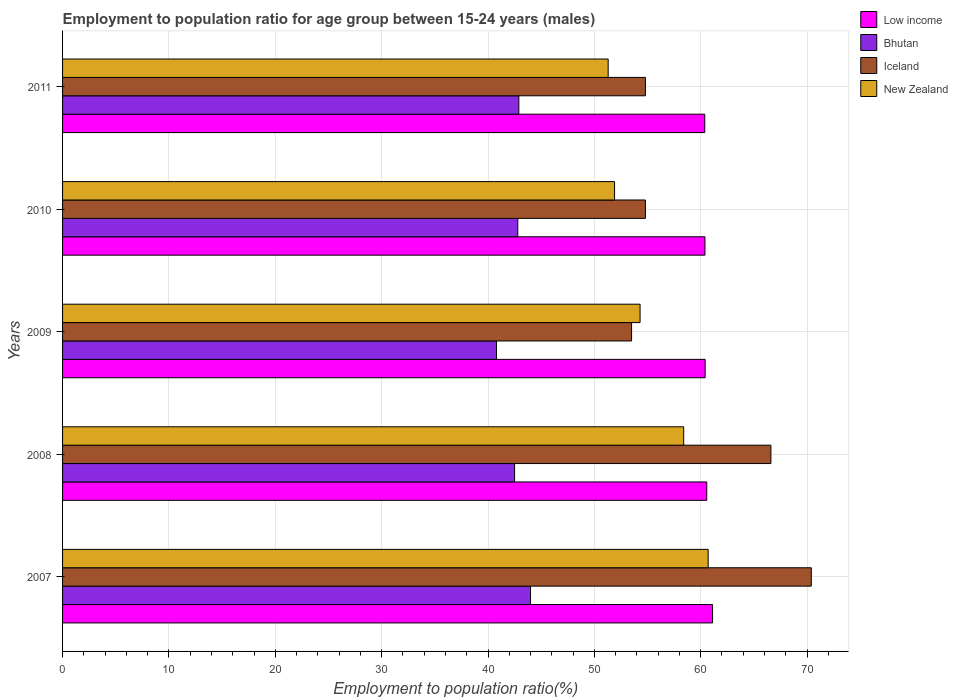How many different coloured bars are there?
Your response must be concise. 4. Are the number of bars on each tick of the Y-axis equal?
Keep it short and to the point. Yes. How many bars are there on the 3rd tick from the bottom?
Give a very brief answer. 4. What is the label of the 3rd group of bars from the top?
Ensure brevity in your answer.  2009. In how many cases, is the number of bars for a given year not equal to the number of legend labels?
Your answer should be very brief. 0. What is the employment to population ratio in New Zealand in 2009?
Offer a terse response. 54.3. Across all years, what is the maximum employment to population ratio in Iceland?
Provide a succinct answer. 70.4. Across all years, what is the minimum employment to population ratio in Bhutan?
Your answer should be compact. 40.8. In which year was the employment to population ratio in Iceland maximum?
Ensure brevity in your answer.  2007. What is the total employment to population ratio in Bhutan in the graph?
Offer a terse response. 213. What is the difference between the employment to population ratio in New Zealand in 2008 and that in 2009?
Provide a succinct answer. 4.1. What is the difference between the employment to population ratio in Iceland in 2010 and the employment to population ratio in Bhutan in 2008?
Make the answer very short. 12.3. What is the average employment to population ratio in Iceland per year?
Ensure brevity in your answer.  60.02. In the year 2009, what is the difference between the employment to population ratio in Low income and employment to population ratio in Iceland?
Give a very brief answer. 6.92. What is the ratio of the employment to population ratio in Iceland in 2008 to that in 2010?
Your response must be concise. 1.22. What is the difference between the highest and the second highest employment to population ratio in Low income?
Offer a very short reply. 0.55. What is the difference between the highest and the lowest employment to population ratio in Iceland?
Your answer should be compact. 16.9. In how many years, is the employment to population ratio in Bhutan greater than the average employment to population ratio in Bhutan taken over all years?
Give a very brief answer. 3. Is the sum of the employment to population ratio in Low income in 2009 and 2010 greater than the maximum employment to population ratio in Iceland across all years?
Keep it short and to the point. Yes. Is it the case that in every year, the sum of the employment to population ratio in Iceland and employment to population ratio in Low income is greater than the sum of employment to population ratio in Bhutan and employment to population ratio in New Zealand?
Provide a short and direct response. Yes. What does the 3rd bar from the top in 2010 represents?
Keep it short and to the point. Bhutan. What does the 4th bar from the bottom in 2010 represents?
Give a very brief answer. New Zealand. Is it the case that in every year, the sum of the employment to population ratio in New Zealand and employment to population ratio in Bhutan is greater than the employment to population ratio in Iceland?
Ensure brevity in your answer.  Yes. How many bars are there?
Ensure brevity in your answer.  20. Are all the bars in the graph horizontal?
Ensure brevity in your answer.  Yes. How many years are there in the graph?
Your answer should be compact. 5. Does the graph contain any zero values?
Your answer should be compact. No. Does the graph contain grids?
Provide a short and direct response. Yes. Where does the legend appear in the graph?
Offer a terse response. Top right. How many legend labels are there?
Your response must be concise. 4. How are the legend labels stacked?
Keep it short and to the point. Vertical. What is the title of the graph?
Provide a short and direct response. Employment to population ratio for age group between 15-24 years (males). What is the label or title of the X-axis?
Your answer should be compact. Employment to population ratio(%). What is the Employment to population ratio(%) in Low income in 2007?
Provide a succinct answer. 61.11. What is the Employment to population ratio(%) in Bhutan in 2007?
Your answer should be compact. 44. What is the Employment to population ratio(%) of Iceland in 2007?
Your answer should be very brief. 70.4. What is the Employment to population ratio(%) of New Zealand in 2007?
Your response must be concise. 60.7. What is the Employment to population ratio(%) in Low income in 2008?
Ensure brevity in your answer.  60.57. What is the Employment to population ratio(%) of Bhutan in 2008?
Your answer should be compact. 42.5. What is the Employment to population ratio(%) of Iceland in 2008?
Ensure brevity in your answer.  66.6. What is the Employment to population ratio(%) in New Zealand in 2008?
Keep it short and to the point. 58.4. What is the Employment to population ratio(%) in Low income in 2009?
Keep it short and to the point. 60.42. What is the Employment to population ratio(%) of Bhutan in 2009?
Ensure brevity in your answer.  40.8. What is the Employment to population ratio(%) of Iceland in 2009?
Keep it short and to the point. 53.5. What is the Employment to population ratio(%) of New Zealand in 2009?
Your answer should be compact. 54.3. What is the Employment to population ratio(%) of Low income in 2010?
Give a very brief answer. 60.4. What is the Employment to population ratio(%) in Bhutan in 2010?
Make the answer very short. 42.8. What is the Employment to population ratio(%) in Iceland in 2010?
Ensure brevity in your answer.  54.8. What is the Employment to population ratio(%) in New Zealand in 2010?
Give a very brief answer. 51.9. What is the Employment to population ratio(%) in Low income in 2011?
Provide a succinct answer. 60.38. What is the Employment to population ratio(%) of Bhutan in 2011?
Make the answer very short. 42.9. What is the Employment to population ratio(%) of Iceland in 2011?
Provide a succinct answer. 54.8. What is the Employment to population ratio(%) in New Zealand in 2011?
Make the answer very short. 51.3. Across all years, what is the maximum Employment to population ratio(%) of Low income?
Ensure brevity in your answer.  61.11. Across all years, what is the maximum Employment to population ratio(%) of Iceland?
Provide a short and direct response. 70.4. Across all years, what is the maximum Employment to population ratio(%) of New Zealand?
Your answer should be very brief. 60.7. Across all years, what is the minimum Employment to population ratio(%) of Low income?
Keep it short and to the point. 60.38. Across all years, what is the minimum Employment to population ratio(%) in Bhutan?
Make the answer very short. 40.8. Across all years, what is the minimum Employment to population ratio(%) of Iceland?
Your response must be concise. 53.5. Across all years, what is the minimum Employment to population ratio(%) in New Zealand?
Give a very brief answer. 51.3. What is the total Employment to population ratio(%) in Low income in the graph?
Keep it short and to the point. 302.88. What is the total Employment to population ratio(%) of Bhutan in the graph?
Keep it short and to the point. 213. What is the total Employment to population ratio(%) in Iceland in the graph?
Offer a terse response. 300.1. What is the total Employment to population ratio(%) of New Zealand in the graph?
Provide a succinct answer. 276.6. What is the difference between the Employment to population ratio(%) in Low income in 2007 and that in 2008?
Provide a succinct answer. 0.55. What is the difference between the Employment to population ratio(%) of Low income in 2007 and that in 2009?
Offer a terse response. 0.7. What is the difference between the Employment to population ratio(%) of Bhutan in 2007 and that in 2009?
Offer a terse response. 3.2. What is the difference between the Employment to population ratio(%) in Iceland in 2007 and that in 2009?
Make the answer very short. 16.9. What is the difference between the Employment to population ratio(%) of Low income in 2007 and that in 2010?
Your answer should be very brief. 0.72. What is the difference between the Employment to population ratio(%) of Iceland in 2007 and that in 2010?
Ensure brevity in your answer.  15.6. What is the difference between the Employment to population ratio(%) in Low income in 2007 and that in 2011?
Offer a terse response. 0.73. What is the difference between the Employment to population ratio(%) of Low income in 2008 and that in 2009?
Your answer should be compact. 0.15. What is the difference between the Employment to population ratio(%) in Bhutan in 2008 and that in 2009?
Offer a very short reply. 1.7. What is the difference between the Employment to population ratio(%) in New Zealand in 2008 and that in 2009?
Ensure brevity in your answer.  4.1. What is the difference between the Employment to population ratio(%) of Low income in 2008 and that in 2010?
Keep it short and to the point. 0.17. What is the difference between the Employment to population ratio(%) in Bhutan in 2008 and that in 2010?
Your response must be concise. -0.3. What is the difference between the Employment to population ratio(%) of Iceland in 2008 and that in 2010?
Give a very brief answer. 11.8. What is the difference between the Employment to population ratio(%) in Low income in 2008 and that in 2011?
Offer a terse response. 0.19. What is the difference between the Employment to population ratio(%) of Bhutan in 2008 and that in 2011?
Offer a terse response. -0.4. What is the difference between the Employment to population ratio(%) in Iceland in 2008 and that in 2011?
Keep it short and to the point. 11.8. What is the difference between the Employment to population ratio(%) of Low income in 2009 and that in 2010?
Offer a terse response. 0.02. What is the difference between the Employment to population ratio(%) of Iceland in 2009 and that in 2010?
Provide a succinct answer. -1.3. What is the difference between the Employment to population ratio(%) in Low income in 2009 and that in 2011?
Give a very brief answer. 0.03. What is the difference between the Employment to population ratio(%) of Bhutan in 2009 and that in 2011?
Your answer should be very brief. -2.1. What is the difference between the Employment to population ratio(%) in Iceland in 2009 and that in 2011?
Ensure brevity in your answer.  -1.3. What is the difference between the Employment to population ratio(%) in Low income in 2010 and that in 2011?
Ensure brevity in your answer.  0.02. What is the difference between the Employment to population ratio(%) of Low income in 2007 and the Employment to population ratio(%) of Bhutan in 2008?
Provide a short and direct response. 18.61. What is the difference between the Employment to population ratio(%) in Low income in 2007 and the Employment to population ratio(%) in Iceland in 2008?
Offer a very short reply. -5.49. What is the difference between the Employment to population ratio(%) in Low income in 2007 and the Employment to population ratio(%) in New Zealand in 2008?
Make the answer very short. 2.71. What is the difference between the Employment to population ratio(%) of Bhutan in 2007 and the Employment to population ratio(%) of Iceland in 2008?
Make the answer very short. -22.6. What is the difference between the Employment to population ratio(%) of Bhutan in 2007 and the Employment to population ratio(%) of New Zealand in 2008?
Your answer should be very brief. -14.4. What is the difference between the Employment to population ratio(%) of Iceland in 2007 and the Employment to population ratio(%) of New Zealand in 2008?
Make the answer very short. 12. What is the difference between the Employment to population ratio(%) in Low income in 2007 and the Employment to population ratio(%) in Bhutan in 2009?
Ensure brevity in your answer.  20.31. What is the difference between the Employment to population ratio(%) of Low income in 2007 and the Employment to population ratio(%) of Iceland in 2009?
Make the answer very short. 7.61. What is the difference between the Employment to population ratio(%) of Low income in 2007 and the Employment to population ratio(%) of New Zealand in 2009?
Offer a terse response. 6.81. What is the difference between the Employment to population ratio(%) of Bhutan in 2007 and the Employment to population ratio(%) of New Zealand in 2009?
Provide a succinct answer. -10.3. What is the difference between the Employment to population ratio(%) of Iceland in 2007 and the Employment to population ratio(%) of New Zealand in 2009?
Offer a terse response. 16.1. What is the difference between the Employment to population ratio(%) in Low income in 2007 and the Employment to population ratio(%) in Bhutan in 2010?
Provide a succinct answer. 18.31. What is the difference between the Employment to population ratio(%) of Low income in 2007 and the Employment to population ratio(%) of Iceland in 2010?
Keep it short and to the point. 6.31. What is the difference between the Employment to population ratio(%) of Low income in 2007 and the Employment to population ratio(%) of New Zealand in 2010?
Offer a terse response. 9.21. What is the difference between the Employment to population ratio(%) of Iceland in 2007 and the Employment to population ratio(%) of New Zealand in 2010?
Your answer should be compact. 18.5. What is the difference between the Employment to population ratio(%) of Low income in 2007 and the Employment to population ratio(%) of Bhutan in 2011?
Your answer should be compact. 18.21. What is the difference between the Employment to population ratio(%) of Low income in 2007 and the Employment to population ratio(%) of Iceland in 2011?
Give a very brief answer. 6.31. What is the difference between the Employment to population ratio(%) of Low income in 2007 and the Employment to population ratio(%) of New Zealand in 2011?
Give a very brief answer. 9.81. What is the difference between the Employment to population ratio(%) of Bhutan in 2007 and the Employment to population ratio(%) of Iceland in 2011?
Offer a very short reply. -10.8. What is the difference between the Employment to population ratio(%) in Bhutan in 2007 and the Employment to population ratio(%) in New Zealand in 2011?
Make the answer very short. -7.3. What is the difference between the Employment to population ratio(%) of Iceland in 2007 and the Employment to population ratio(%) of New Zealand in 2011?
Ensure brevity in your answer.  19.1. What is the difference between the Employment to population ratio(%) in Low income in 2008 and the Employment to population ratio(%) in Bhutan in 2009?
Your response must be concise. 19.77. What is the difference between the Employment to population ratio(%) in Low income in 2008 and the Employment to population ratio(%) in Iceland in 2009?
Your answer should be compact. 7.07. What is the difference between the Employment to population ratio(%) of Low income in 2008 and the Employment to population ratio(%) of New Zealand in 2009?
Offer a very short reply. 6.27. What is the difference between the Employment to population ratio(%) in Bhutan in 2008 and the Employment to population ratio(%) in New Zealand in 2009?
Offer a terse response. -11.8. What is the difference between the Employment to population ratio(%) of Iceland in 2008 and the Employment to population ratio(%) of New Zealand in 2009?
Offer a terse response. 12.3. What is the difference between the Employment to population ratio(%) of Low income in 2008 and the Employment to population ratio(%) of Bhutan in 2010?
Keep it short and to the point. 17.77. What is the difference between the Employment to population ratio(%) in Low income in 2008 and the Employment to population ratio(%) in Iceland in 2010?
Your response must be concise. 5.77. What is the difference between the Employment to population ratio(%) of Low income in 2008 and the Employment to population ratio(%) of New Zealand in 2010?
Make the answer very short. 8.67. What is the difference between the Employment to population ratio(%) of Low income in 2008 and the Employment to population ratio(%) of Bhutan in 2011?
Give a very brief answer. 17.67. What is the difference between the Employment to population ratio(%) in Low income in 2008 and the Employment to population ratio(%) in Iceland in 2011?
Make the answer very short. 5.77. What is the difference between the Employment to population ratio(%) in Low income in 2008 and the Employment to population ratio(%) in New Zealand in 2011?
Offer a very short reply. 9.27. What is the difference between the Employment to population ratio(%) in Bhutan in 2008 and the Employment to population ratio(%) in Iceland in 2011?
Offer a terse response. -12.3. What is the difference between the Employment to population ratio(%) in Bhutan in 2008 and the Employment to population ratio(%) in New Zealand in 2011?
Keep it short and to the point. -8.8. What is the difference between the Employment to population ratio(%) in Low income in 2009 and the Employment to population ratio(%) in Bhutan in 2010?
Your response must be concise. 17.62. What is the difference between the Employment to population ratio(%) in Low income in 2009 and the Employment to population ratio(%) in Iceland in 2010?
Your response must be concise. 5.62. What is the difference between the Employment to population ratio(%) in Low income in 2009 and the Employment to population ratio(%) in New Zealand in 2010?
Give a very brief answer. 8.52. What is the difference between the Employment to population ratio(%) of Bhutan in 2009 and the Employment to population ratio(%) of Iceland in 2010?
Offer a terse response. -14. What is the difference between the Employment to population ratio(%) in Low income in 2009 and the Employment to population ratio(%) in Bhutan in 2011?
Your answer should be compact. 17.52. What is the difference between the Employment to population ratio(%) of Low income in 2009 and the Employment to population ratio(%) of Iceland in 2011?
Offer a terse response. 5.62. What is the difference between the Employment to population ratio(%) of Low income in 2009 and the Employment to population ratio(%) of New Zealand in 2011?
Offer a very short reply. 9.12. What is the difference between the Employment to population ratio(%) of Bhutan in 2009 and the Employment to population ratio(%) of New Zealand in 2011?
Your answer should be compact. -10.5. What is the difference between the Employment to population ratio(%) of Low income in 2010 and the Employment to population ratio(%) of Bhutan in 2011?
Keep it short and to the point. 17.5. What is the difference between the Employment to population ratio(%) in Low income in 2010 and the Employment to population ratio(%) in Iceland in 2011?
Provide a short and direct response. 5.6. What is the difference between the Employment to population ratio(%) in Low income in 2010 and the Employment to population ratio(%) in New Zealand in 2011?
Give a very brief answer. 9.1. What is the difference between the Employment to population ratio(%) of Bhutan in 2010 and the Employment to population ratio(%) of New Zealand in 2011?
Provide a short and direct response. -8.5. What is the difference between the Employment to population ratio(%) of Iceland in 2010 and the Employment to population ratio(%) of New Zealand in 2011?
Your response must be concise. 3.5. What is the average Employment to population ratio(%) of Low income per year?
Ensure brevity in your answer.  60.58. What is the average Employment to population ratio(%) of Bhutan per year?
Ensure brevity in your answer.  42.6. What is the average Employment to population ratio(%) in Iceland per year?
Offer a terse response. 60.02. What is the average Employment to population ratio(%) in New Zealand per year?
Your response must be concise. 55.32. In the year 2007, what is the difference between the Employment to population ratio(%) of Low income and Employment to population ratio(%) of Bhutan?
Provide a short and direct response. 17.11. In the year 2007, what is the difference between the Employment to population ratio(%) in Low income and Employment to population ratio(%) in Iceland?
Your answer should be very brief. -9.29. In the year 2007, what is the difference between the Employment to population ratio(%) in Low income and Employment to population ratio(%) in New Zealand?
Provide a short and direct response. 0.41. In the year 2007, what is the difference between the Employment to population ratio(%) in Bhutan and Employment to population ratio(%) in Iceland?
Provide a short and direct response. -26.4. In the year 2007, what is the difference between the Employment to population ratio(%) in Bhutan and Employment to population ratio(%) in New Zealand?
Your answer should be very brief. -16.7. In the year 2008, what is the difference between the Employment to population ratio(%) in Low income and Employment to population ratio(%) in Bhutan?
Give a very brief answer. 18.07. In the year 2008, what is the difference between the Employment to population ratio(%) of Low income and Employment to population ratio(%) of Iceland?
Give a very brief answer. -6.03. In the year 2008, what is the difference between the Employment to population ratio(%) of Low income and Employment to population ratio(%) of New Zealand?
Offer a very short reply. 2.17. In the year 2008, what is the difference between the Employment to population ratio(%) in Bhutan and Employment to population ratio(%) in Iceland?
Offer a terse response. -24.1. In the year 2008, what is the difference between the Employment to population ratio(%) in Bhutan and Employment to population ratio(%) in New Zealand?
Provide a succinct answer. -15.9. In the year 2009, what is the difference between the Employment to population ratio(%) of Low income and Employment to population ratio(%) of Bhutan?
Your answer should be very brief. 19.62. In the year 2009, what is the difference between the Employment to population ratio(%) of Low income and Employment to population ratio(%) of Iceland?
Give a very brief answer. 6.92. In the year 2009, what is the difference between the Employment to population ratio(%) of Low income and Employment to population ratio(%) of New Zealand?
Offer a terse response. 6.12. In the year 2010, what is the difference between the Employment to population ratio(%) of Low income and Employment to population ratio(%) of Bhutan?
Provide a short and direct response. 17.6. In the year 2010, what is the difference between the Employment to population ratio(%) in Low income and Employment to population ratio(%) in Iceland?
Offer a terse response. 5.6. In the year 2010, what is the difference between the Employment to population ratio(%) in Low income and Employment to population ratio(%) in New Zealand?
Your response must be concise. 8.5. In the year 2010, what is the difference between the Employment to population ratio(%) of Bhutan and Employment to population ratio(%) of Iceland?
Give a very brief answer. -12. In the year 2010, what is the difference between the Employment to population ratio(%) in Bhutan and Employment to population ratio(%) in New Zealand?
Offer a very short reply. -9.1. In the year 2010, what is the difference between the Employment to population ratio(%) in Iceland and Employment to population ratio(%) in New Zealand?
Give a very brief answer. 2.9. In the year 2011, what is the difference between the Employment to population ratio(%) of Low income and Employment to population ratio(%) of Bhutan?
Provide a short and direct response. 17.48. In the year 2011, what is the difference between the Employment to population ratio(%) in Low income and Employment to population ratio(%) in Iceland?
Make the answer very short. 5.58. In the year 2011, what is the difference between the Employment to population ratio(%) of Low income and Employment to population ratio(%) of New Zealand?
Your response must be concise. 9.08. In the year 2011, what is the difference between the Employment to population ratio(%) in Bhutan and Employment to population ratio(%) in Iceland?
Offer a very short reply. -11.9. In the year 2011, what is the difference between the Employment to population ratio(%) of Bhutan and Employment to population ratio(%) of New Zealand?
Ensure brevity in your answer.  -8.4. What is the ratio of the Employment to population ratio(%) in Bhutan in 2007 to that in 2008?
Keep it short and to the point. 1.04. What is the ratio of the Employment to population ratio(%) of Iceland in 2007 to that in 2008?
Make the answer very short. 1.06. What is the ratio of the Employment to population ratio(%) in New Zealand in 2007 to that in 2008?
Your response must be concise. 1.04. What is the ratio of the Employment to population ratio(%) in Low income in 2007 to that in 2009?
Keep it short and to the point. 1.01. What is the ratio of the Employment to population ratio(%) of Bhutan in 2007 to that in 2009?
Offer a terse response. 1.08. What is the ratio of the Employment to population ratio(%) of Iceland in 2007 to that in 2009?
Ensure brevity in your answer.  1.32. What is the ratio of the Employment to population ratio(%) of New Zealand in 2007 to that in 2009?
Keep it short and to the point. 1.12. What is the ratio of the Employment to population ratio(%) of Low income in 2007 to that in 2010?
Make the answer very short. 1.01. What is the ratio of the Employment to population ratio(%) in Bhutan in 2007 to that in 2010?
Make the answer very short. 1.03. What is the ratio of the Employment to population ratio(%) of Iceland in 2007 to that in 2010?
Your answer should be compact. 1.28. What is the ratio of the Employment to population ratio(%) in New Zealand in 2007 to that in 2010?
Offer a very short reply. 1.17. What is the ratio of the Employment to population ratio(%) of Low income in 2007 to that in 2011?
Provide a succinct answer. 1.01. What is the ratio of the Employment to population ratio(%) of Bhutan in 2007 to that in 2011?
Offer a very short reply. 1.03. What is the ratio of the Employment to population ratio(%) of Iceland in 2007 to that in 2011?
Your response must be concise. 1.28. What is the ratio of the Employment to population ratio(%) in New Zealand in 2007 to that in 2011?
Keep it short and to the point. 1.18. What is the ratio of the Employment to population ratio(%) in Bhutan in 2008 to that in 2009?
Your answer should be compact. 1.04. What is the ratio of the Employment to population ratio(%) of Iceland in 2008 to that in 2009?
Ensure brevity in your answer.  1.24. What is the ratio of the Employment to population ratio(%) in New Zealand in 2008 to that in 2009?
Offer a terse response. 1.08. What is the ratio of the Employment to population ratio(%) in Iceland in 2008 to that in 2010?
Your answer should be compact. 1.22. What is the ratio of the Employment to population ratio(%) in New Zealand in 2008 to that in 2010?
Give a very brief answer. 1.13. What is the ratio of the Employment to population ratio(%) of Iceland in 2008 to that in 2011?
Your response must be concise. 1.22. What is the ratio of the Employment to population ratio(%) in New Zealand in 2008 to that in 2011?
Your answer should be compact. 1.14. What is the ratio of the Employment to population ratio(%) in Bhutan in 2009 to that in 2010?
Provide a succinct answer. 0.95. What is the ratio of the Employment to population ratio(%) of Iceland in 2009 to that in 2010?
Your answer should be compact. 0.98. What is the ratio of the Employment to population ratio(%) in New Zealand in 2009 to that in 2010?
Your answer should be compact. 1.05. What is the ratio of the Employment to population ratio(%) in Bhutan in 2009 to that in 2011?
Offer a terse response. 0.95. What is the ratio of the Employment to population ratio(%) in Iceland in 2009 to that in 2011?
Give a very brief answer. 0.98. What is the ratio of the Employment to population ratio(%) of New Zealand in 2009 to that in 2011?
Provide a succinct answer. 1.06. What is the ratio of the Employment to population ratio(%) in New Zealand in 2010 to that in 2011?
Keep it short and to the point. 1.01. What is the difference between the highest and the second highest Employment to population ratio(%) of Low income?
Provide a succinct answer. 0.55. What is the difference between the highest and the second highest Employment to population ratio(%) in Bhutan?
Your answer should be compact. 1.1. What is the difference between the highest and the second highest Employment to population ratio(%) of New Zealand?
Your answer should be very brief. 2.3. What is the difference between the highest and the lowest Employment to population ratio(%) in Low income?
Provide a short and direct response. 0.73. What is the difference between the highest and the lowest Employment to population ratio(%) in Bhutan?
Your answer should be compact. 3.2. What is the difference between the highest and the lowest Employment to population ratio(%) of New Zealand?
Provide a succinct answer. 9.4. 